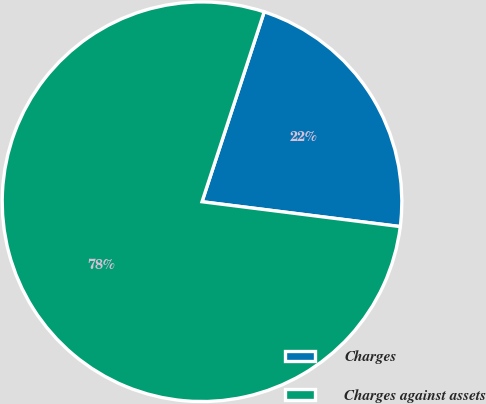Convert chart. <chart><loc_0><loc_0><loc_500><loc_500><pie_chart><fcel>Charges<fcel>Charges against assets<nl><fcel>21.95%<fcel>78.05%<nl></chart> 